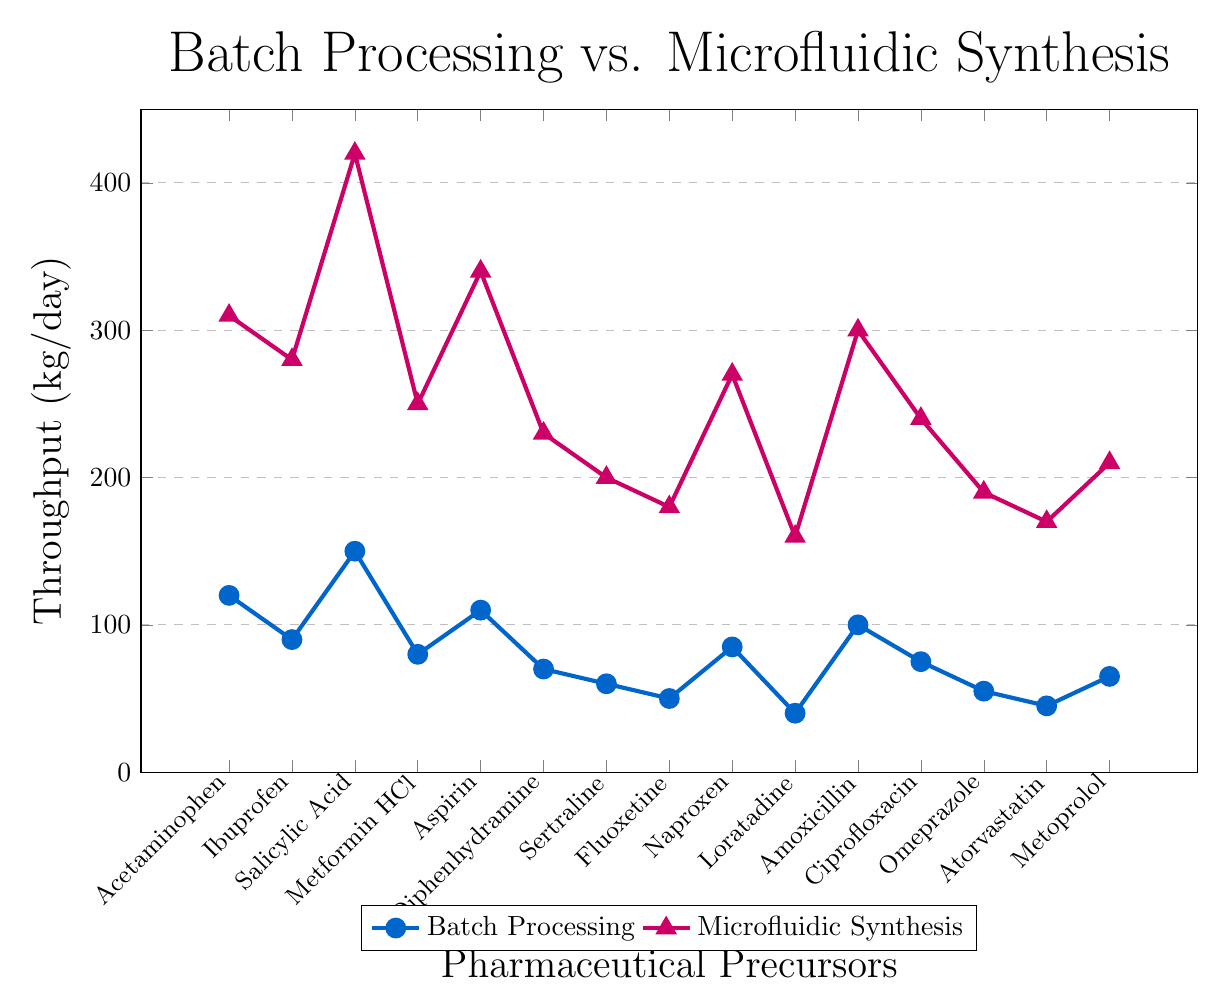What's the difference in throughput for Salicylic Acid between batch processing and microfluidic synthesis? The figure shows that batch processing has a throughput of 150 kg/day, whereas microfluidic synthesis has a throughput of 420 kg/day. The difference is calculated as 420 - 150.
Answer: 270 kg/day Which precursor shows the smallest throughput difference between batch processing and microfluidic synthesis? To find the precursor with the smallest throughput difference, calculate the difference for each precursor: Acetaminophen (310-120 = 190), Ibuprofen (280-90 = 190), Salicylic Acid (420-150 = 270), Metformin HCl (250-80 = 170), Aspirin (340-110 = 230), Diphenhydramine (230-70 = 160), Sertraline (200-60 = 140), Fluoxetine (180-50 = 130), Naproxen (270-85 = 185), Loratadine (160-40 = 120), Amoxicillin (300-100 = 200), Ciprofloxacin (240-75 = 165), Omeprazole (190-55 = 135), Atorvastatin (170-45 = 125), Metoprolol (210-65 = 145). Loratadine has the smallest difference at 120 kg/day.
Answer: Loratadine How many precursors have a throughput greater than 300 kg/day in microfluidic synthesis? Observing the microfluidic synthesis throughput values, we see that Acetaminophen (310), Salicylic Acid (420), Aspirin (340), and Amoxicillin (300) have throughputs greater than or equal to 300 kg/day.
Answer: 4 Which processing method is shown by a line with triangle markers? The plot includes two lines, one with circular markers and one with triangle markers. The legend indicates that the line with triangle markers represents microfluidic synthesis.
Answer: Microfluidic synthesis What is the average throughput of batch processing for Ibuprofen, Aspirin, and Amoxicillin? The throughput values for these precursors are Ibuprofen (90), Aspirin (110), and Amoxicillin (100). The average is calculated as (90 + 110 + 100) / 3.
Answer: 100 kg/day 